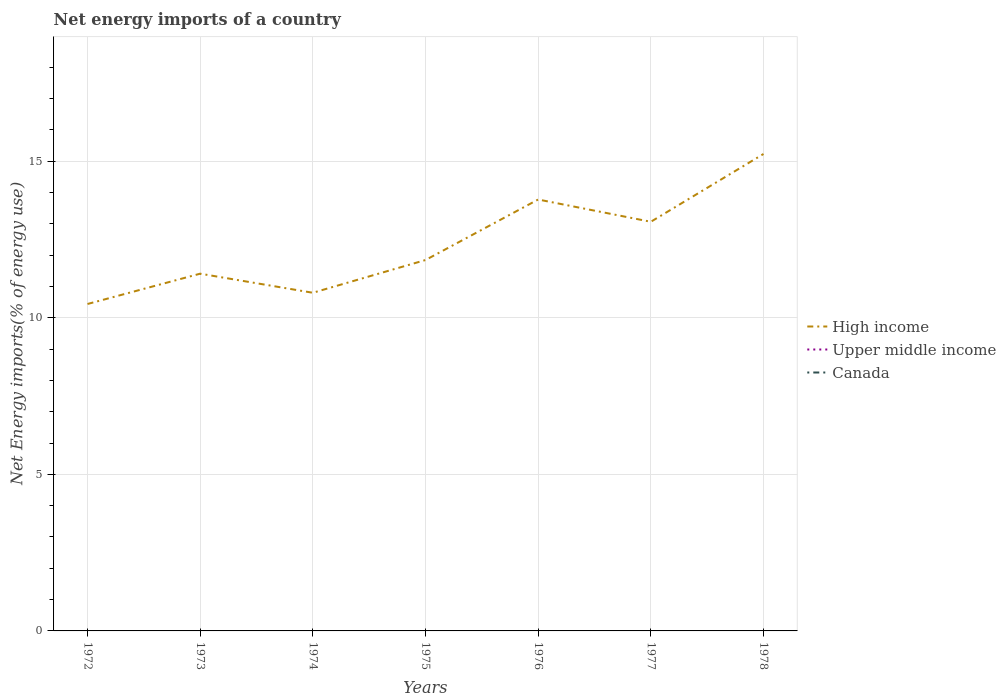How many different coloured lines are there?
Your answer should be compact. 1. Is the number of lines equal to the number of legend labels?
Ensure brevity in your answer.  No. Across all years, what is the maximum net energy imports in Canada?
Provide a short and direct response. 0. What is the total net energy imports in High income in the graph?
Offer a terse response. -2.27. What is the difference between the highest and the second highest net energy imports in High income?
Your answer should be very brief. 4.79. What is the difference between the highest and the lowest net energy imports in Upper middle income?
Provide a short and direct response. 0. Is the net energy imports in High income strictly greater than the net energy imports in Canada over the years?
Your response must be concise. No. How many lines are there?
Your answer should be very brief. 1. How many years are there in the graph?
Make the answer very short. 7. Where does the legend appear in the graph?
Your response must be concise. Center right. How are the legend labels stacked?
Make the answer very short. Vertical. What is the title of the graph?
Offer a terse response. Net energy imports of a country. Does "Kuwait" appear as one of the legend labels in the graph?
Your answer should be compact. No. What is the label or title of the Y-axis?
Provide a succinct answer. Net Energy imports(% of energy use). What is the Net Energy imports(% of energy use) of High income in 1972?
Your answer should be compact. 10.44. What is the Net Energy imports(% of energy use) of High income in 1973?
Make the answer very short. 11.41. What is the Net Energy imports(% of energy use) in Upper middle income in 1973?
Your answer should be compact. 0. What is the Net Energy imports(% of energy use) of High income in 1974?
Make the answer very short. 10.8. What is the Net Energy imports(% of energy use) in Canada in 1974?
Offer a terse response. 0. What is the Net Energy imports(% of energy use) in High income in 1975?
Offer a very short reply. 11.84. What is the Net Energy imports(% of energy use) of High income in 1976?
Offer a terse response. 13.77. What is the Net Energy imports(% of energy use) in High income in 1977?
Make the answer very short. 13.06. What is the Net Energy imports(% of energy use) of Canada in 1977?
Offer a very short reply. 0. What is the Net Energy imports(% of energy use) in High income in 1978?
Your response must be concise. 15.23. What is the Net Energy imports(% of energy use) in Upper middle income in 1978?
Keep it short and to the point. 0. Across all years, what is the maximum Net Energy imports(% of energy use) in High income?
Your answer should be very brief. 15.23. Across all years, what is the minimum Net Energy imports(% of energy use) of High income?
Your answer should be very brief. 10.44. What is the total Net Energy imports(% of energy use) of High income in the graph?
Offer a very short reply. 86.55. What is the total Net Energy imports(% of energy use) in Upper middle income in the graph?
Offer a very short reply. 0. What is the difference between the Net Energy imports(% of energy use) in High income in 1972 and that in 1973?
Offer a very short reply. -0.97. What is the difference between the Net Energy imports(% of energy use) in High income in 1972 and that in 1974?
Your response must be concise. -0.36. What is the difference between the Net Energy imports(% of energy use) of High income in 1972 and that in 1975?
Your answer should be compact. -1.4. What is the difference between the Net Energy imports(% of energy use) of High income in 1972 and that in 1976?
Provide a short and direct response. -3.34. What is the difference between the Net Energy imports(% of energy use) in High income in 1972 and that in 1977?
Your answer should be compact. -2.63. What is the difference between the Net Energy imports(% of energy use) of High income in 1972 and that in 1978?
Make the answer very short. -4.79. What is the difference between the Net Energy imports(% of energy use) in High income in 1973 and that in 1974?
Ensure brevity in your answer.  0.61. What is the difference between the Net Energy imports(% of energy use) in High income in 1973 and that in 1975?
Offer a very short reply. -0.44. What is the difference between the Net Energy imports(% of energy use) in High income in 1973 and that in 1976?
Keep it short and to the point. -2.37. What is the difference between the Net Energy imports(% of energy use) in High income in 1973 and that in 1977?
Your response must be concise. -1.66. What is the difference between the Net Energy imports(% of energy use) in High income in 1973 and that in 1978?
Offer a very short reply. -3.82. What is the difference between the Net Energy imports(% of energy use) in High income in 1974 and that in 1975?
Keep it short and to the point. -1.05. What is the difference between the Net Energy imports(% of energy use) of High income in 1974 and that in 1976?
Give a very brief answer. -2.98. What is the difference between the Net Energy imports(% of energy use) of High income in 1974 and that in 1977?
Provide a short and direct response. -2.27. What is the difference between the Net Energy imports(% of energy use) of High income in 1974 and that in 1978?
Keep it short and to the point. -4.43. What is the difference between the Net Energy imports(% of energy use) in High income in 1975 and that in 1976?
Make the answer very short. -1.93. What is the difference between the Net Energy imports(% of energy use) in High income in 1975 and that in 1977?
Offer a very short reply. -1.22. What is the difference between the Net Energy imports(% of energy use) of High income in 1975 and that in 1978?
Provide a short and direct response. -3.39. What is the difference between the Net Energy imports(% of energy use) in High income in 1976 and that in 1977?
Your answer should be very brief. 0.71. What is the difference between the Net Energy imports(% of energy use) of High income in 1976 and that in 1978?
Your answer should be very brief. -1.45. What is the difference between the Net Energy imports(% of energy use) in High income in 1977 and that in 1978?
Offer a very short reply. -2.16. What is the average Net Energy imports(% of energy use) in High income per year?
Your response must be concise. 12.36. What is the average Net Energy imports(% of energy use) in Upper middle income per year?
Make the answer very short. 0. What is the ratio of the Net Energy imports(% of energy use) of High income in 1972 to that in 1973?
Your answer should be very brief. 0.92. What is the ratio of the Net Energy imports(% of energy use) of High income in 1972 to that in 1974?
Provide a short and direct response. 0.97. What is the ratio of the Net Energy imports(% of energy use) of High income in 1972 to that in 1975?
Offer a terse response. 0.88. What is the ratio of the Net Energy imports(% of energy use) of High income in 1972 to that in 1976?
Your response must be concise. 0.76. What is the ratio of the Net Energy imports(% of energy use) of High income in 1972 to that in 1977?
Your response must be concise. 0.8. What is the ratio of the Net Energy imports(% of energy use) in High income in 1972 to that in 1978?
Provide a short and direct response. 0.69. What is the ratio of the Net Energy imports(% of energy use) of High income in 1973 to that in 1974?
Make the answer very short. 1.06. What is the ratio of the Net Energy imports(% of energy use) of High income in 1973 to that in 1975?
Offer a very short reply. 0.96. What is the ratio of the Net Energy imports(% of energy use) in High income in 1973 to that in 1976?
Make the answer very short. 0.83. What is the ratio of the Net Energy imports(% of energy use) of High income in 1973 to that in 1977?
Ensure brevity in your answer.  0.87. What is the ratio of the Net Energy imports(% of energy use) in High income in 1973 to that in 1978?
Keep it short and to the point. 0.75. What is the ratio of the Net Energy imports(% of energy use) in High income in 1974 to that in 1975?
Keep it short and to the point. 0.91. What is the ratio of the Net Energy imports(% of energy use) of High income in 1974 to that in 1976?
Provide a succinct answer. 0.78. What is the ratio of the Net Energy imports(% of energy use) of High income in 1974 to that in 1977?
Give a very brief answer. 0.83. What is the ratio of the Net Energy imports(% of energy use) of High income in 1974 to that in 1978?
Provide a succinct answer. 0.71. What is the ratio of the Net Energy imports(% of energy use) of High income in 1975 to that in 1976?
Offer a terse response. 0.86. What is the ratio of the Net Energy imports(% of energy use) of High income in 1975 to that in 1977?
Your response must be concise. 0.91. What is the ratio of the Net Energy imports(% of energy use) in High income in 1975 to that in 1978?
Ensure brevity in your answer.  0.78. What is the ratio of the Net Energy imports(% of energy use) in High income in 1976 to that in 1977?
Offer a very short reply. 1.05. What is the ratio of the Net Energy imports(% of energy use) in High income in 1976 to that in 1978?
Your answer should be very brief. 0.9. What is the ratio of the Net Energy imports(% of energy use) in High income in 1977 to that in 1978?
Your answer should be compact. 0.86. What is the difference between the highest and the second highest Net Energy imports(% of energy use) of High income?
Keep it short and to the point. 1.45. What is the difference between the highest and the lowest Net Energy imports(% of energy use) in High income?
Your answer should be very brief. 4.79. 